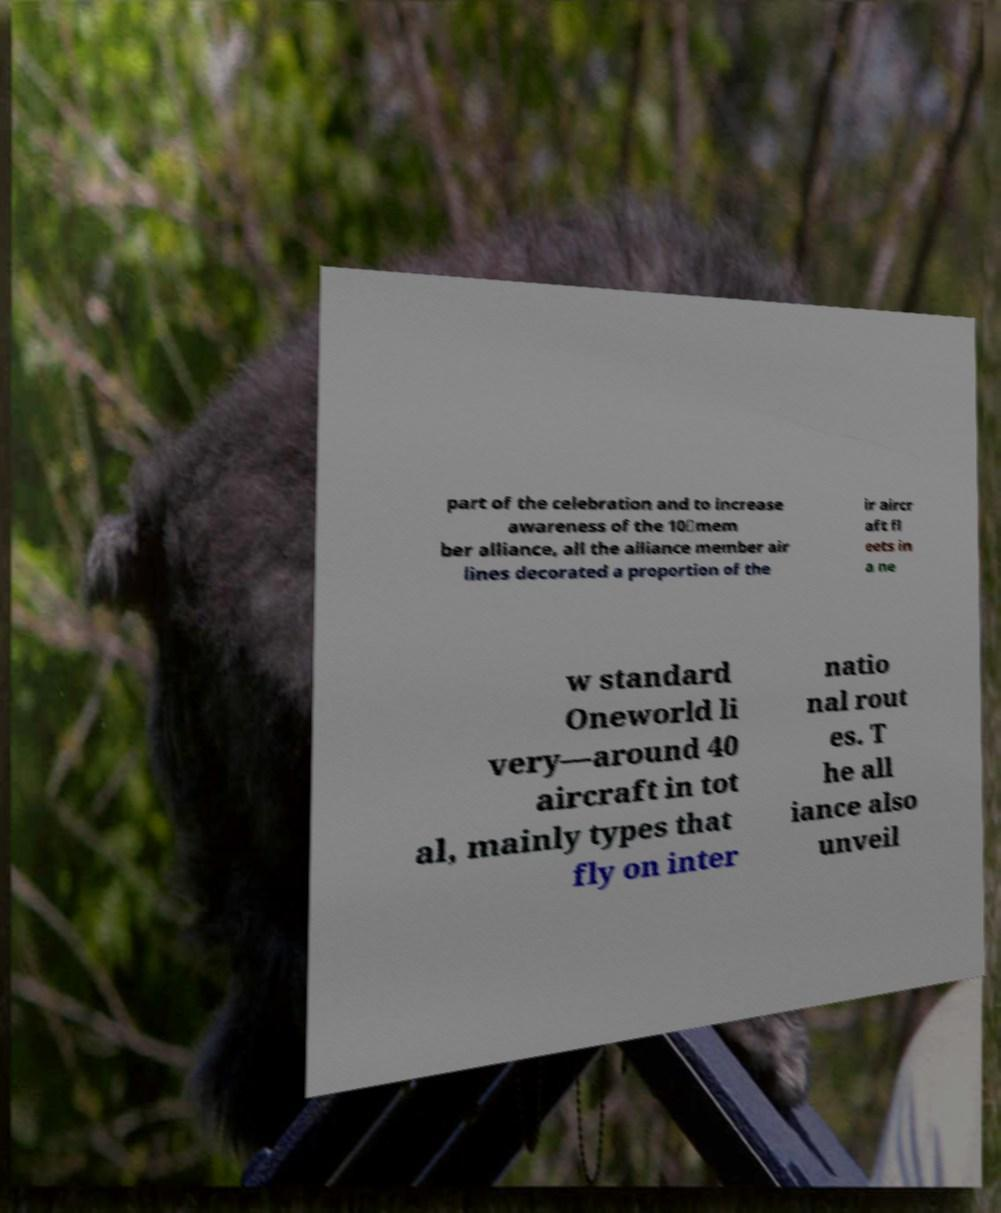What messages or text are displayed in this image? I need them in a readable, typed format. part of the celebration and to increase awareness of the 10‑mem ber alliance, all the alliance member air lines decorated a proportion of the ir aircr aft fl eets in a ne w standard Oneworld li very—around 40 aircraft in tot al, mainly types that fly on inter natio nal rout es. T he all iance also unveil 